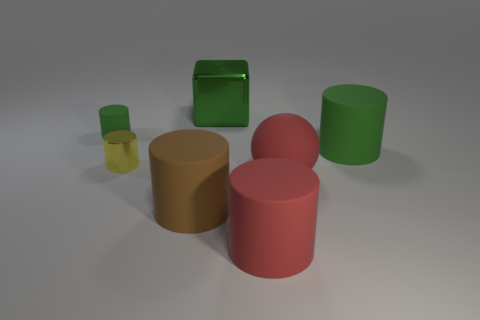What material is the thing that is the same color as the matte ball?
Provide a succinct answer. Rubber. There is a green thing that is behind the tiny cylinder behind the tiny yellow object; is there a big shiny cube that is in front of it?
Offer a very short reply. No. Do the green cylinder that is on the right side of the small metal object and the green block that is right of the brown cylinder have the same material?
Offer a terse response. No. What number of things are small metallic cylinders or green cylinders that are on the left side of the big sphere?
Offer a very short reply. 2. What number of large brown matte objects have the same shape as the yellow object?
Make the answer very short. 1. What material is the green thing that is the same size as the yellow metal cylinder?
Offer a very short reply. Rubber. There is a metal object that is right of the large cylinder that is on the left side of the green object behind the tiny green thing; what size is it?
Your answer should be very brief. Large. There is a big matte thing that is behind the matte ball; is its color the same as the big cylinder to the left of the red matte cylinder?
Your answer should be very brief. No. How many yellow things are either big rubber cylinders or tiny objects?
Your answer should be very brief. 1. How many blocks have the same size as the green shiny thing?
Offer a terse response. 0. 